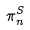Convert formula to latex. <formula><loc_0><loc_0><loc_500><loc_500>\pi _ { n } ^ { S }</formula> 